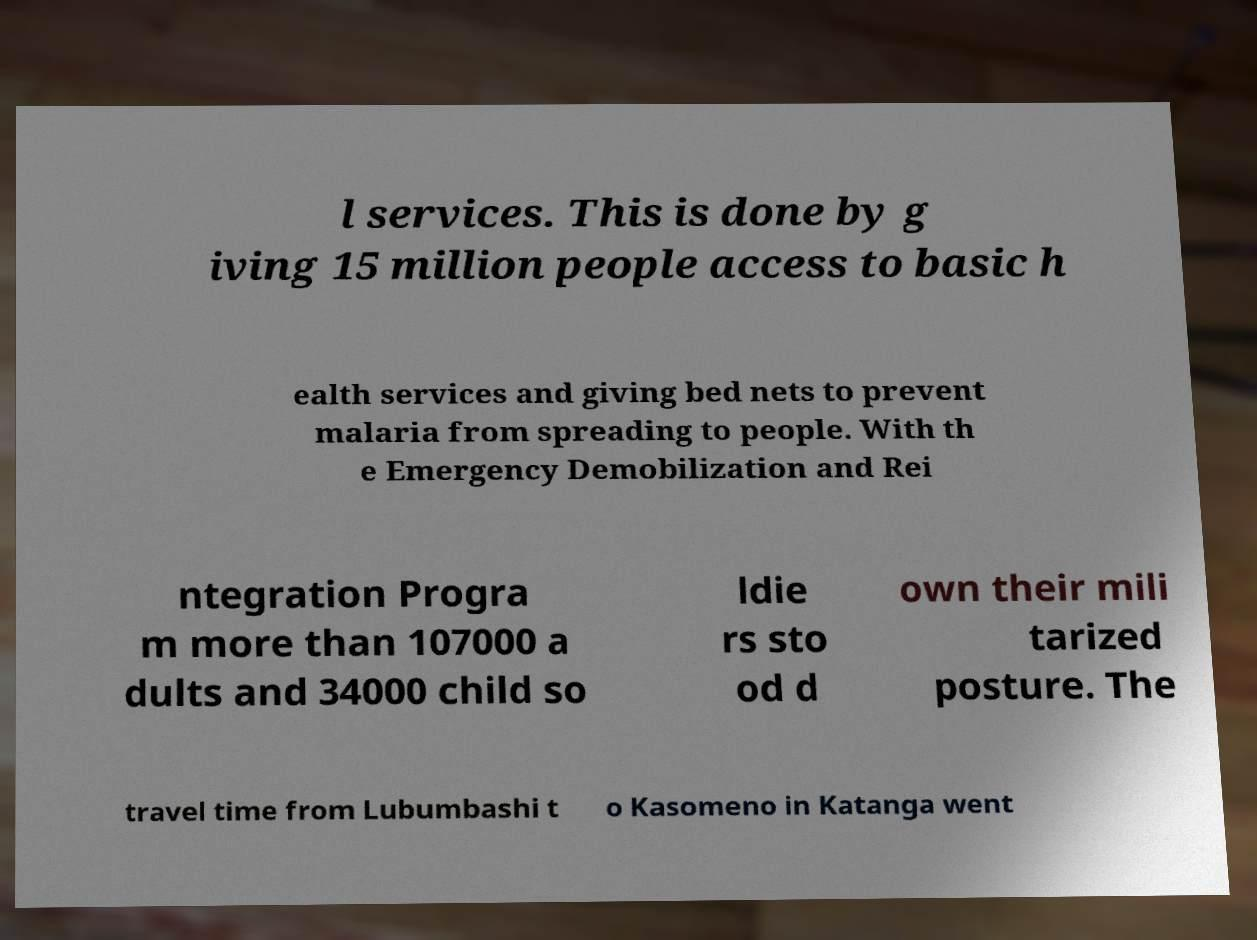I need the written content from this picture converted into text. Can you do that? l services. This is done by g iving 15 million people access to basic h ealth services and giving bed nets to prevent malaria from spreading to people. With th e Emergency Demobilization and Rei ntegration Progra m more than 107000 a dults and 34000 child so ldie rs sto od d own their mili tarized posture. The travel time from Lubumbashi t o Kasomeno in Katanga went 